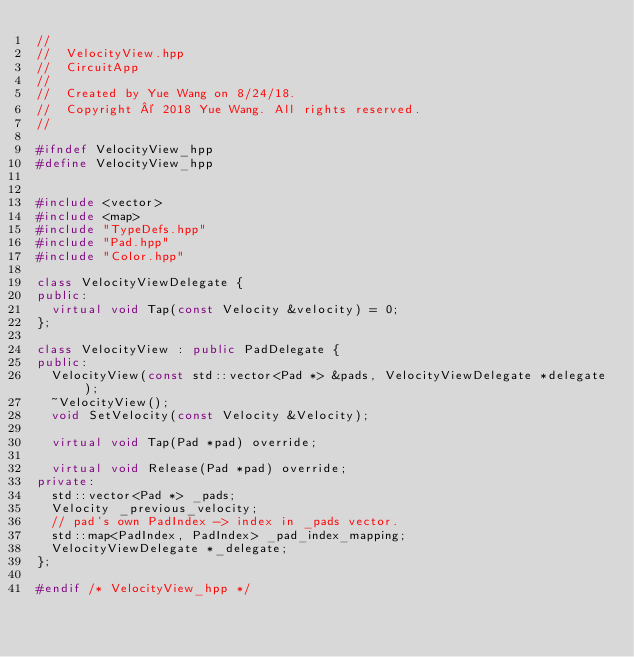Convert code to text. <code><loc_0><loc_0><loc_500><loc_500><_C++_>//
//  VelocityView.hpp
//  CircuitApp
//
//  Created by Yue Wang on 8/24/18.
//  Copyright © 2018 Yue Wang. All rights reserved.
//

#ifndef VelocityView_hpp
#define VelocityView_hpp


#include <vector>
#include <map>
#include "TypeDefs.hpp"
#include "Pad.hpp"
#include "Color.hpp"

class VelocityViewDelegate {
public:
  virtual void Tap(const Velocity &velocity) = 0;
};

class VelocityView : public PadDelegate {
public:
  VelocityView(const std::vector<Pad *> &pads, VelocityViewDelegate *delegate);
  ~VelocityView();
  void SetVelocity(const Velocity &Velocity);
  
  virtual void Tap(Pad *pad) override;
  
  virtual void Release(Pad *pad) override;
private:
  std::vector<Pad *> _pads;
  Velocity _previous_velocity;
  // pad's own PadIndex -> index in _pads vector.
  std::map<PadIndex, PadIndex> _pad_index_mapping;
  VelocityViewDelegate *_delegate;
};

#endif /* VelocityView_hpp */
</code> 